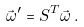Convert formula to latex. <formula><loc_0><loc_0><loc_500><loc_500>\vec { \omega } ^ { \prime } = S ^ { T } \vec { \omega } \, .</formula> 